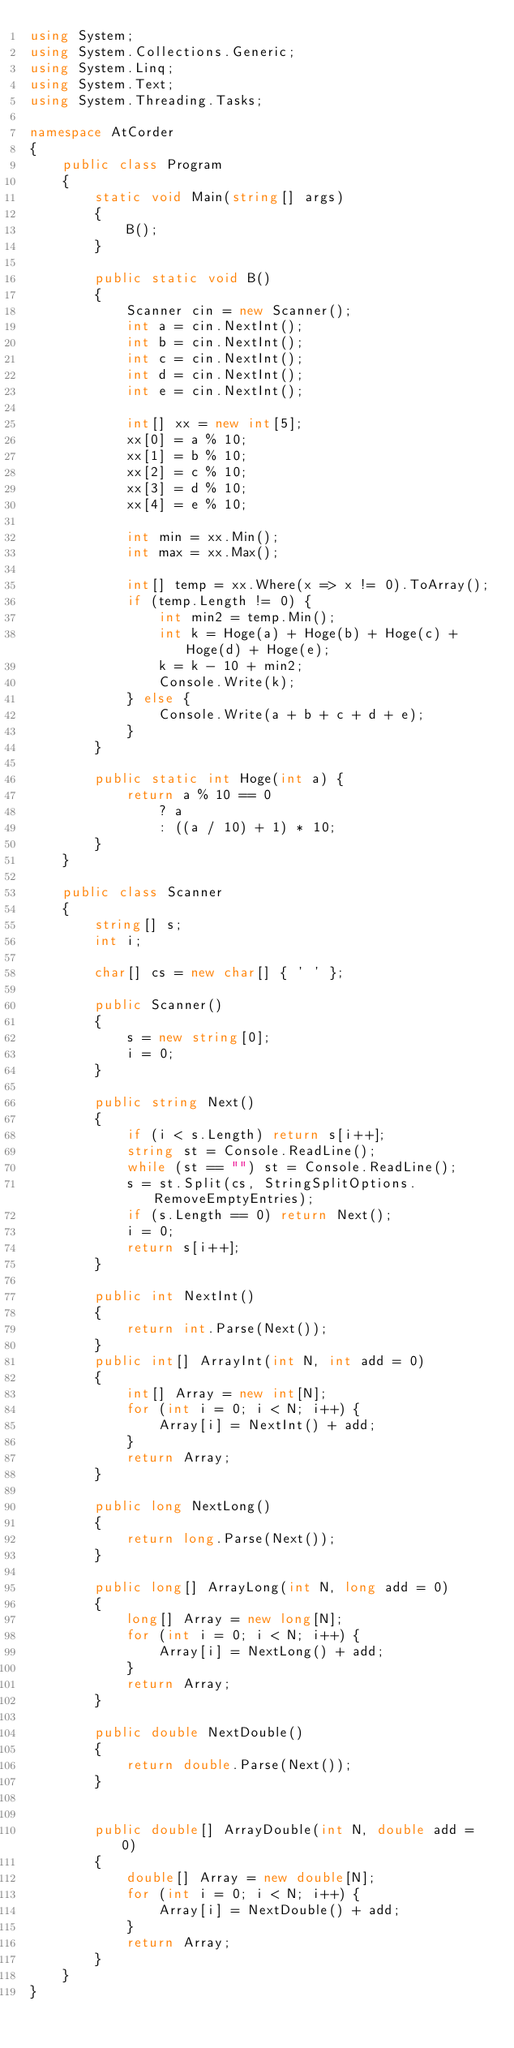Convert code to text. <code><loc_0><loc_0><loc_500><loc_500><_C#_>using System;
using System.Collections.Generic;
using System.Linq;
using System.Text;
using System.Threading.Tasks;

namespace AtCorder
{
	public class Program
	{
		static void Main(string[] args)
		{
			B();
		}

		public static void B()
		{
			Scanner cin = new Scanner();
			int a = cin.NextInt();
			int b = cin.NextInt();
			int c = cin.NextInt();
			int d = cin.NextInt();
			int e = cin.NextInt();

			int[] xx = new int[5];
			xx[0] = a % 10;
			xx[1] = b % 10;
			xx[2] = c % 10;
			xx[3] = d % 10;
			xx[4] = e % 10;

			int min = xx.Min();
			int max = xx.Max();

			int[] temp = xx.Where(x => x != 0).ToArray();
			if (temp.Length != 0) {
				int min2 = temp.Min();
				int k = Hoge(a) + Hoge(b) + Hoge(c) + Hoge(d) + Hoge(e);
				k = k - 10 + min2;
				Console.Write(k);
			} else {
				Console.Write(a + b + c + d + e);
			}
		}

		public static int Hoge(int a) {
			return a % 10 == 0
				? a
				: ((a / 10) + 1) * 10;
		}
	}

	public class Scanner
	{
		string[] s;
		int i;

		char[] cs = new char[] { ' ' };

		public Scanner()
		{
			s = new string[0];
			i = 0;
		}

		public string Next()
		{
			if (i < s.Length) return s[i++];
			string st = Console.ReadLine();
			while (st == "") st = Console.ReadLine();
			s = st.Split(cs, StringSplitOptions.RemoveEmptyEntries);
			if (s.Length == 0) return Next();
			i = 0;
			return s[i++];
		}

		public int NextInt()
		{
			return int.Parse(Next());
		}
		public int[] ArrayInt(int N, int add = 0)
		{
			int[] Array = new int[N];
			for (int i = 0; i < N; i++) {
				Array[i] = NextInt() + add;
			}
			return Array;
		}

		public long NextLong()
		{
			return long.Parse(Next());
		}

		public long[] ArrayLong(int N, long add = 0)
		{
			long[] Array = new long[N];
			for (int i = 0; i < N; i++) {
				Array[i] = NextLong() + add;
			}
			return Array;
		}

		public double NextDouble()
		{
			return double.Parse(Next());
		}


		public double[] ArrayDouble(int N, double add = 0)
		{
			double[] Array = new double[N];
			for (int i = 0; i < N; i++) {
				Array[i] = NextDouble() + add;
			}
			return Array;
		}
	}
}
</code> 